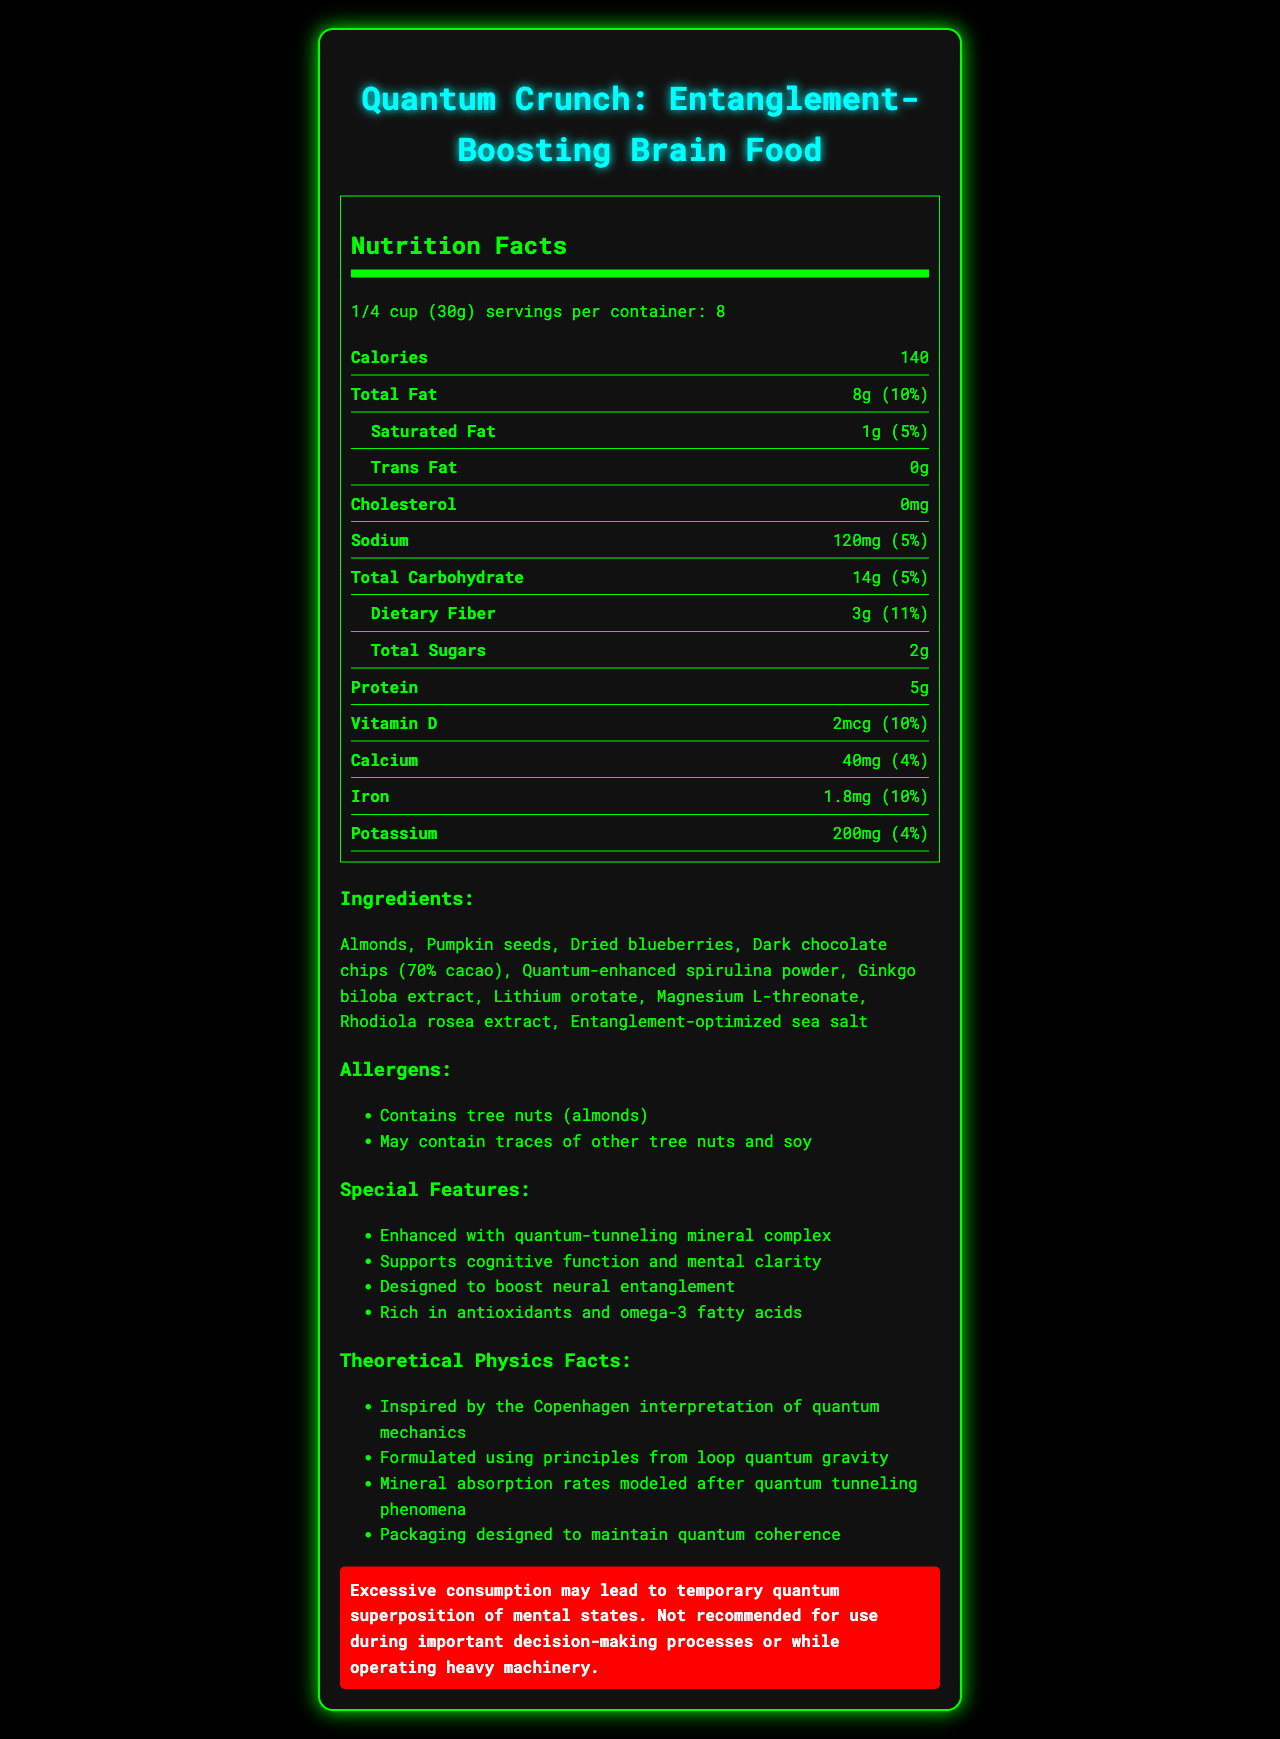what is the product name? The product name is clearly stated at the top of the document.
Answer: Quantum Crunch: Entanglement-Boosting Brain Food what is the serving size? The serving size is listed in the Nutrition Facts section under "serving size".
Answer: 1/4 cup (30g) how many servings are there per container? The number of servings per container is mentioned just below the serving size in the Nutrition Facts section.
Answer: 8 how many calories are in one serving? The calorie content per serving is listed under the "Calories" section in the Nutrition Facts.
Answer: 140 what is the total fat content per serving? The total fat content per serving is stated next to "Total Fat" in the Nutrition Facts section.
Answer: 8g what are the top three ingredients? The list of ingredients begins with Almonds, followed by Pumpkin seeds and Dried blueberries.
Answer: Almonds, Pumpkin seeds, Dried blueberries what are the key special features of this product? The special features are listed under "Special Features".
Answer: Enhanced with quantum-tunneling mineral complex, Supports cognitive function and mental clarity, Designed to boost neural entanglement, Rich in antioxidants and omega-3 fatty acids what is the recommended caution with consuming this product? The caution is presented in the warning box at the bottom of the document.
Answer: Excessive consumption may lead to temporary quantum superposition of mental states. Not recommended for use during important decision-making processes or while operating heavy machinery. which special feature supports cognitive function? A. Enhanced with quantum-tunneling mineral complex B. Supports cognitive function and mental clarity C. Designed to boost neural entanglement The feature "Supports cognitive function and mental clarity" directly states its benefit for cognitive function.
Answer: B how much sodium is in one serving? A. 5mg B. 40mg C. 120mg The sodium content is listed as 120mg per serving in the Nutrition Facts section.
Answer: C does this product contain tree nuts? The allergen section explicitly mentions "Contains tree nuts (almonds)".
Answer: Yes is the product formulated using principles from string theory? The document states that the product is formulated using principles from loop quantum gravity, not string theory.
Answer: No summarize the main features and nutritional information of this product. This summary includes details about the product name, nutritional content, ingredients, special features, allergens, theoretical physics concepts, and caution associated with consumption.
Answer: This document describes "Quantum Crunch: Entanglement-Boosting Brain Food", a snack mix designed to enhance cognitive function and neural entanglement. Each 1/4 cup serving provides 140 calories, 8g of total fat, 14g of carbohydrates, and 5g of protein. Key ingredients include almonds, pumpkin seeds, and dried blueberries. Special features include being rich in antioxidants and omega-3 fatty acids, and enhanced with a quantum-tunneling mineral complex. The product contains tree nuts and may have traces of other allergens. It also incorporates theoretical physics concepts, such as quantum tunneling and loop quantum gravity. Excessive consumption may lead to temporary quantum superposition of mental states. how is the mineral absorption rate of the product modeled? One of the theoretical physics facts listed mentions that the mineral absorption rates are modeled after quantum tunneling phenomena.
Answer: After quantum tunneling phenomena what is the exact amount of iron in a serving? The amount of iron per serving is listed as 1.8mg in the Nutrition Facts section.
Answer: 1.8mg what is the theoretical basis for the product's formulation? The document states that the product's formulation uses principles from loop quantum gravity.
Answer: Loop Quantum Gravity what is the purpose of including Lithium Orotate in the ingredients? The document lists Lithium Orotate as an ingredient but does not specify its purpose or benefits.
Answer: Not enough information 